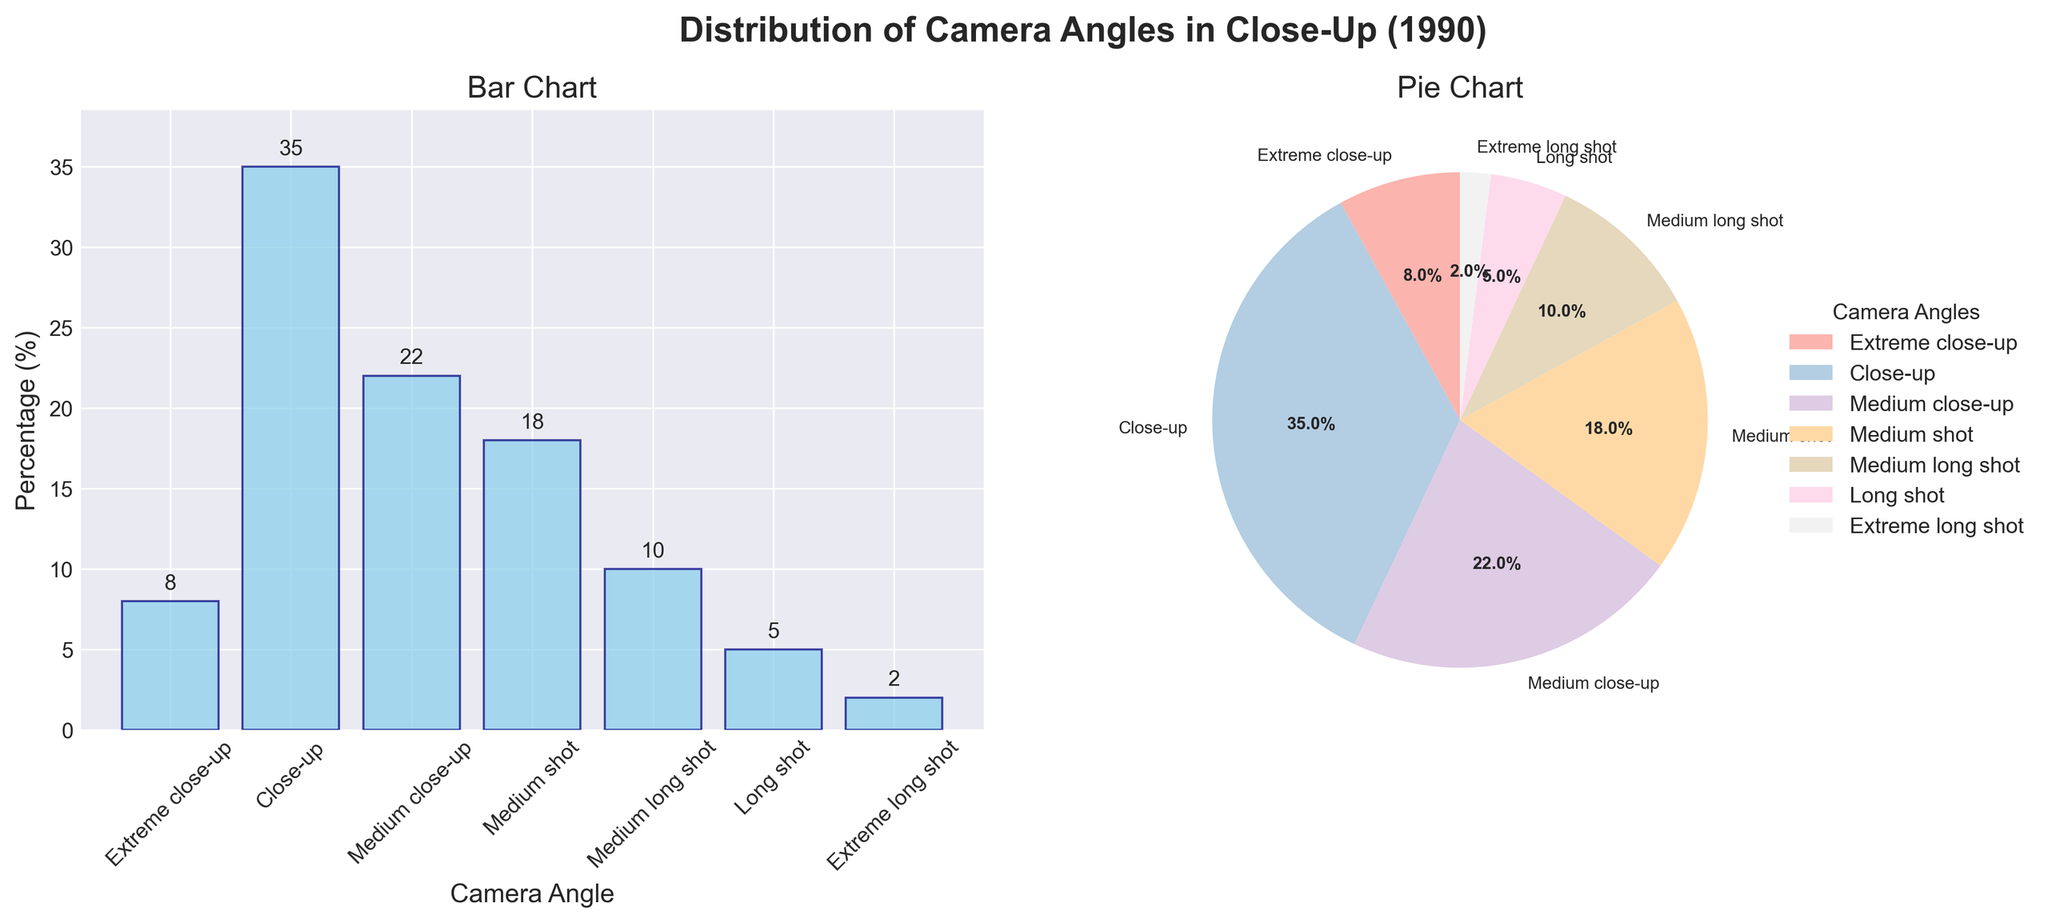Which camera angle has the highest percentage in Close-Up (1990)? The bar chart and the pie chart both show that "Close-up" has the highest percentage with a value of 35%.
Answer: Close-up Which camera angle has the lowest percentage in Close-Up (1990)? The bar chart and the pie chart both show that "Extreme long shot" has the lowest percentage with a value of 2%.
Answer: Extreme long shot What is the combined percentage of Medium close-up and Medium shot angles? The percentage for Medium close-up is 22% and for Medium shot is 18%, so their combined percentage is 22 + 18 = 40%.
Answer: 40% Which camera angles have a percentage greater than 20%? From the bar chart, "Close-up" (35%) and "Medium close-up" (22%) are the camera angles with percentages greater than 20%.
Answer: Close-up, Medium close-up What is the difference in percentage between the Close-up and Extreme close-up angles? According to the bar chart, the percentage for Close-up is 35% while it is 8% for Extreme close-up. The difference is 35 - 8 = 27%.
Answer: 27% Are there more camera angles with percentages less than 10% or more than 10%? From the bar chart, angles less than 10% are: Long shot (5%) and Extreme long shot (2%)—total of 2 angles. Angles more than 10% are: Close-up (35%), Medium close-up (22%), Medium shot (18%), and Medium long shot (10%)—total of 4 angles. Thus, there are more camera angles with percentages more than 10%.
Answer: More than 10% How does the use of Medium shots compare to Extreme long shots in terms of percentage? The bar chart indicates that Medium shots account for 18% while Extreme long shots account for only 2%. Therefore, Medium shots are used much more frequently than Extreme long shots.
Answer: Medium shots are much more frequent Which three camera angles are used the most, and what is their combined percentage? The three most used camera angles from the bar chart are Close-up (35%), Medium close-up (22%), and Medium shot (18%). Their combined percentage is 35 + 22 + 18 = 75%.
Answer: Close-up, Medium close-up, Medium shot, 75% What is the median percentage value of the camera angles? To find the median, first list the percentages in ascending order: 2, 5, 8, 10, 18, 22, 35. The median is the middle value, which is 10%.
Answer: 10% How many camera angles have a percentage of exactly 8%? From the bar chart, only the Extreme close-up angle has a percentage of exactly 8%.
Answer: 1 